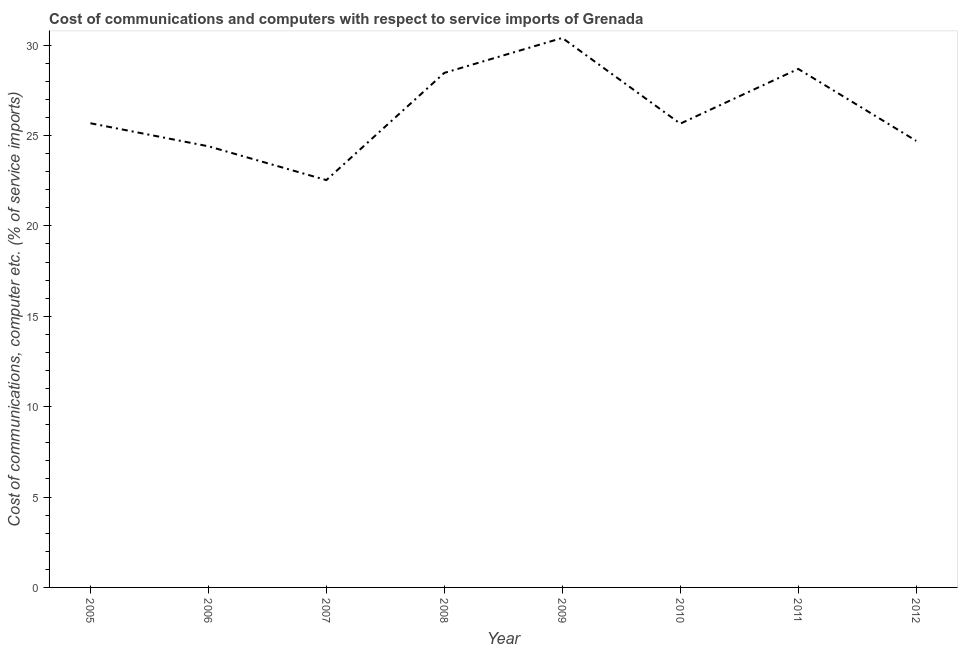What is the cost of communications and computer in 2008?
Give a very brief answer. 28.46. Across all years, what is the maximum cost of communications and computer?
Your answer should be compact. 30.4. Across all years, what is the minimum cost of communications and computer?
Make the answer very short. 22.53. What is the sum of the cost of communications and computer?
Offer a very short reply. 210.52. What is the difference between the cost of communications and computer in 2009 and 2010?
Your response must be concise. 4.74. What is the average cost of communications and computer per year?
Keep it short and to the point. 26.31. What is the median cost of communications and computer?
Your answer should be very brief. 25.67. In how many years, is the cost of communications and computer greater than 10 %?
Provide a succinct answer. 8. Do a majority of the years between 2009 and 2007 (inclusive) have cost of communications and computer greater than 20 %?
Make the answer very short. No. What is the ratio of the cost of communications and computer in 2007 to that in 2009?
Make the answer very short. 0.74. Is the cost of communications and computer in 2010 less than that in 2012?
Keep it short and to the point. No. Is the difference between the cost of communications and computer in 2007 and 2010 greater than the difference between any two years?
Make the answer very short. No. What is the difference between the highest and the second highest cost of communications and computer?
Keep it short and to the point. 1.71. Is the sum of the cost of communications and computer in 2008 and 2010 greater than the maximum cost of communications and computer across all years?
Provide a succinct answer. Yes. What is the difference between the highest and the lowest cost of communications and computer?
Ensure brevity in your answer.  7.86. In how many years, is the cost of communications and computer greater than the average cost of communications and computer taken over all years?
Make the answer very short. 3. Does the cost of communications and computer monotonically increase over the years?
Give a very brief answer. No. How many lines are there?
Your answer should be very brief. 1. How many years are there in the graph?
Keep it short and to the point. 8. What is the title of the graph?
Your answer should be very brief. Cost of communications and computers with respect to service imports of Grenada. What is the label or title of the Y-axis?
Provide a succinct answer. Cost of communications, computer etc. (% of service imports). What is the Cost of communications, computer etc. (% of service imports) in 2005?
Offer a very short reply. 25.68. What is the Cost of communications, computer etc. (% of service imports) in 2006?
Make the answer very short. 24.4. What is the Cost of communications, computer etc. (% of service imports) of 2007?
Your response must be concise. 22.53. What is the Cost of communications, computer etc. (% of service imports) in 2008?
Provide a short and direct response. 28.46. What is the Cost of communications, computer etc. (% of service imports) of 2009?
Provide a short and direct response. 30.4. What is the Cost of communications, computer etc. (% of service imports) of 2010?
Make the answer very short. 25.66. What is the Cost of communications, computer etc. (% of service imports) of 2011?
Provide a succinct answer. 28.68. What is the Cost of communications, computer etc. (% of service imports) of 2012?
Give a very brief answer. 24.7. What is the difference between the Cost of communications, computer etc. (% of service imports) in 2005 and 2006?
Provide a succinct answer. 1.27. What is the difference between the Cost of communications, computer etc. (% of service imports) in 2005 and 2007?
Ensure brevity in your answer.  3.14. What is the difference between the Cost of communications, computer etc. (% of service imports) in 2005 and 2008?
Offer a very short reply. -2.79. What is the difference between the Cost of communications, computer etc. (% of service imports) in 2005 and 2009?
Your answer should be very brief. -4.72. What is the difference between the Cost of communications, computer etc. (% of service imports) in 2005 and 2010?
Offer a very short reply. 0.02. What is the difference between the Cost of communications, computer etc. (% of service imports) in 2005 and 2011?
Offer a terse response. -3.01. What is the difference between the Cost of communications, computer etc. (% of service imports) in 2005 and 2012?
Provide a short and direct response. 0.98. What is the difference between the Cost of communications, computer etc. (% of service imports) in 2006 and 2007?
Give a very brief answer. 1.87. What is the difference between the Cost of communications, computer etc. (% of service imports) in 2006 and 2008?
Provide a succinct answer. -4.06. What is the difference between the Cost of communications, computer etc. (% of service imports) in 2006 and 2009?
Offer a terse response. -5.99. What is the difference between the Cost of communications, computer etc. (% of service imports) in 2006 and 2010?
Offer a terse response. -1.25. What is the difference between the Cost of communications, computer etc. (% of service imports) in 2006 and 2011?
Your response must be concise. -4.28. What is the difference between the Cost of communications, computer etc. (% of service imports) in 2006 and 2012?
Offer a very short reply. -0.3. What is the difference between the Cost of communications, computer etc. (% of service imports) in 2007 and 2008?
Keep it short and to the point. -5.93. What is the difference between the Cost of communications, computer etc. (% of service imports) in 2007 and 2009?
Your answer should be very brief. -7.86. What is the difference between the Cost of communications, computer etc. (% of service imports) in 2007 and 2010?
Ensure brevity in your answer.  -3.12. What is the difference between the Cost of communications, computer etc. (% of service imports) in 2007 and 2011?
Offer a very short reply. -6.15. What is the difference between the Cost of communications, computer etc. (% of service imports) in 2007 and 2012?
Provide a succinct answer. -2.17. What is the difference between the Cost of communications, computer etc. (% of service imports) in 2008 and 2009?
Provide a short and direct response. -1.93. What is the difference between the Cost of communications, computer etc. (% of service imports) in 2008 and 2010?
Your answer should be very brief. 2.81. What is the difference between the Cost of communications, computer etc. (% of service imports) in 2008 and 2011?
Offer a terse response. -0.22. What is the difference between the Cost of communications, computer etc. (% of service imports) in 2008 and 2012?
Ensure brevity in your answer.  3.76. What is the difference between the Cost of communications, computer etc. (% of service imports) in 2009 and 2010?
Ensure brevity in your answer.  4.74. What is the difference between the Cost of communications, computer etc. (% of service imports) in 2009 and 2011?
Your response must be concise. 1.71. What is the difference between the Cost of communications, computer etc. (% of service imports) in 2009 and 2012?
Ensure brevity in your answer.  5.69. What is the difference between the Cost of communications, computer etc. (% of service imports) in 2010 and 2011?
Offer a very short reply. -3.03. What is the difference between the Cost of communications, computer etc. (% of service imports) in 2010 and 2012?
Provide a succinct answer. 0.95. What is the difference between the Cost of communications, computer etc. (% of service imports) in 2011 and 2012?
Ensure brevity in your answer.  3.98. What is the ratio of the Cost of communications, computer etc. (% of service imports) in 2005 to that in 2006?
Offer a very short reply. 1.05. What is the ratio of the Cost of communications, computer etc. (% of service imports) in 2005 to that in 2007?
Provide a short and direct response. 1.14. What is the ratio of the Cost of communications, computer etc. (% of service imports) in 2005 to that in 2008?
Make the answer very short. 0.9. What is the ratio of the Cost of communications, computer etc. (% of service imports) in 2005 to that in 2009?
Keep it short and to the point. 0.84. What is the ratio of the Cost of communications, computer etc. (% of service imports) in 2005 to that in 2011?
Offer a very short reply. 0.9. What is the ratio of the Cost of communications, computer etc. (% of service imports) in 2005 to that in 2012?
Your answer should be compact. 1.04. What is the ratio of the Cost of communications, computer etc. (% of service imports) in 2006 to that in 2007?
Your answer should be compact. 1.08. What is the ratio of the Cost of communications, computer etc. (% of service imports) in 2006 to that in 2008?
Provide a short and direct response. 0.86. What is the ratio of the Cost of communications, computer etc. (% of service imports) in 2006 to that in 2009?
Your response must be concise. 0.8. What is the ratio of the Cost of communications, computer etc. (% of service imports) in 2006 to that in 2010?
Your answer should be very brief. 0.95. What is the ratio of the Cost of communications, computer etc. (% of service imports) in 2006 to that in 2011?
Make the answer very short. 0.85. What is the ratio of the Cost of communications, computer etc. (% of service imports) in 2007 to that in 2008?
Your response must be concise. 0.79. What is the ratio of the Cost of communications, computer etc. (% of service imports) in 2007 to that in 2009?
Keep it short and to the point. 0.74. What is the ratio of the Cost of communications, computer etc. (% of service imports) in 2007 to that in 2010?
Your answer should be compact. 0.88. What is the ratio of the Cost of communications, computer etc. (% of service imports) in 2007 to that in 2011?
Offer a terse response. 0.79. What is the ratio of the Cost of communications, computer etc. (% of service imports) in 2007 to that in 2012?
Your answer should be compact. 0.91. What is the ratio of the Cost of communications, computer etc. (% of service imports) in 2008 to that in 2009?
Give a very brief answer. 0.94. What is the ratio of the Cost of communications, computer etc. (% of service imports) in 2008 to that in 2010?
Offer a terse response. 1.11. What is the ratio of the Cost of communications, computer etc. (% of service imports) in 2008 to that in 2012?
Provide a short and direct response. 1.15. What is the ratio of the Cost of communications, computer etc. (% of service imports) in 2009 to that in 2010?
Provide a short and direct response. 1.19. What is the ratio of the Cost of communications, computer etc. (% of service imports) in 2009 to that in 2011?
Give a very brief answer. 1.06. What is the ratio of the Cost of communications, computer etc. (% of service imports) in 2009 to that in 2012?
Offer a terse response. 1.23. What is the ratio of the Cost of communications, computer etc. (% of service imports) in 2010 to that in 2011?
Make the answer very short. 0.89. What is the ratio of the Cost of communications, computer etc. (% of service imports) in 2010 to that in 2012?
Offer a very short reply. 1.04. What is the ratio of the Cost of communications, computer etc. (% of service imports) in 2011 to that in 2012?
Keep it short and to the point. 1.16. 